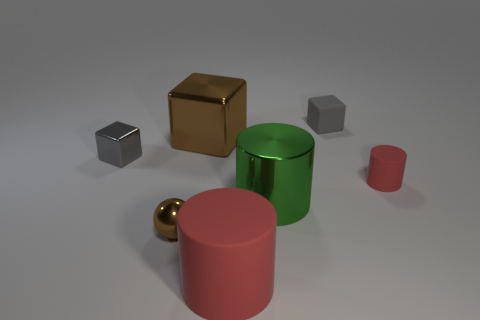How many spheres are gray things or big red matte things?
Ensure brevity in your answer.  0. How big is the matte object that is to the left of the tiny red matte cylinder and in front of the gray rubber thing?
Ensure brevity in your answer.  Large. How many other objects are there of the same color as the metallic cylinder?
Keep it short and to the point. 0. Does the large green object have the same material as the tiny gray thing in front of the tiny matte cube?
Keep it short and to the point. Yes. How many objects are either brown shiny objects behind the tiny gray metal object or big brown objects?
Keep it short and to the point. 1. What shape is the small object that is in front of the rubber cube and to the right of the brown shiny ball?
Offer a very short reply. Cylinder. The cylinder that is the same material as the small red object is what size?
Provide a succinct answer. Large. What number of objects are either objects that are behind the small brown object or small rubber things right of the gray rubber object?
Make the answer very short. 5. Is the size of the green cylinder in front of the brown metal cube the same as the tiny cylinder?
Your response must be concise. No. What color is the small metallic thing left of the small brown shiny object?
Ensure brevity in your answer.  Gray. 